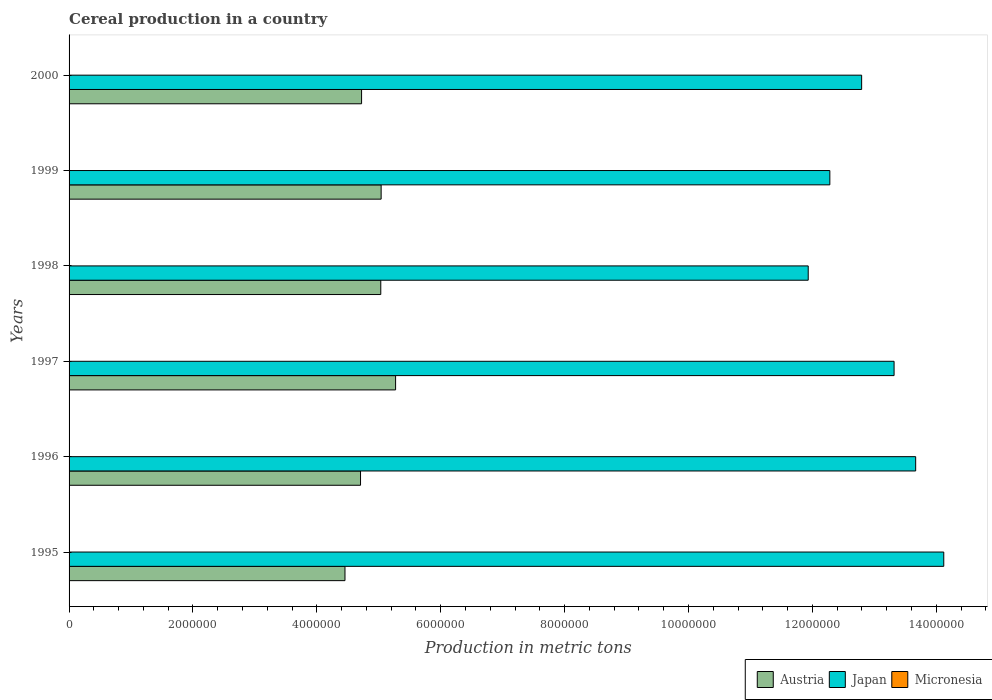Are the number of bars per tick equal to the number of legend labels?
Your response must be concise. Yes. Are the number of bars on each tick of the Y-axis equal?
Ensure brevity in your answer.  Yes. How many bars are there on the 3rd tick from the top?
Ensure brevity in your answer.  3. How many bars are there on the 4th tick from the bottom?
Your response must be concise. 3. In how many cases, is the number of bars for a given year not equal to the number of legend labels?
Your answer should be very brief. 0. What is the total cereal production in Austria in 1997?
Ensure brevity in your answer.  5.27e+06. Across all years, what is the maximum total cereal production in Austria?
Your answer should be very brief. 5.27e+06. Across all years, what is the minimum total cereal production in Japan?
Provide a short and direct response. 1.19e+07. In which year was the total cereal production in Japan maximum?
Offer a very short reply. 1995. What is the total total cereal production in Japan in the graph?
Keep it short and to the point. 7.81e+07. What is the difference between the total cereal production in Japan in 1996 and that in 1998?
Keep it short and to the point. 1.73e+06. What is the difference between the total cereal production in Micronesia in 1995 and the total cereal production in Japan in 1999?
Provide a succinct answer. -1.23e+07. What is the average total cereal production in Micronesia per year?
Keep it short and to the point. 148. In the year 2000, what is the difference between the total cereal production in Micronesia and total cereal production in Austria?
Keep it short and to the point. -4.72e+06. In how many years, is the total cereal production in Austria greater than 6000000 metric tons?
Your answer should be very brief. 0. What is the ratio of the total cereal production in Japan in 1997 to that in 1998?
Keep it short and to the point. 1.12. Is the difference between the total cereal production in Micronesia in 1999 and 2000 greater than the difference between the total cereal production in Austria in 1999 and 2000?
Your response must be concise. No. What is the difference between the highest and the second highest total cereal production in Austria?
Ensure brevity in your answer.  2.33e+05. What is the difference between the highest and the lowest total cereal production in Micronesia?
Ensure brevity in your answer.  23. What does the 3rd bar from the bottom in 1998 represents?
Ensure brevity in your answer.  Micronesia. How many bars are there?
Give a very brief answer. 18. Are all the bars in the graph horizontal?
Keep it short and to the point. Yes. What is the difference between two consecutive major ticks on the X-axis?
Your response must be concise. 2.00e+06. Does the graph contain any zero values?
Give a very brief answer. No. Does the graph contain grids?
Your response must be concise. No. Where does the legend appear in the graph?
Provide a succinct answer. Bottom right. What is the title of the graph?
Your answer should be compact. Cereal production in a country. Does "St. Lucia" appear as one of the legend labels in the graph?
Ensure brevity in your answer.  No. What is the label or title of the X-axis?
Provide a short and direct response. Production in metric tons. What is the label or title of the Y-axis?
Offer a very short reply. Years. What is the Production in metric tons in Austria in 1995?
Provide a short and direct response. 4.45e+06. What is the Production in metric tons of Japan in 1995?
Offer a very short reply. 1.41e+07. What is the Production in metric tons in Micronesia in 1995?
Provide a short and direct response. 148. What is the Production in metric tons in Austria in 1996?
Your answer should be compact. 4.71e+06. What is the Production in metric tons in Japan in 1996?
Your answer should be compact. 1.37e+07. What is the Production in metric tons of Micronesia in 1996?
Keep it short and to the point. 152. What is the Production in metric tons in Austria in 1997?
Ensure brevity in your answer.  5.27e+06. What is the Production in metric tons of Japan in 1997?
Ensure brevity in your answer.  1.33e+07. What is the Production in metric tons in Micronesia in 1997?
Provide a short and direct response. 149. What is the Production in metric tons of Austria in 1998?
Make the answer very short. 5.03e+06. What is the Production in metric tons in Japan in 1998?
Your response must be concise. 1.19e+07. What is the Production in metric tons in Micronesia in 1998?
Provide a succinct answer. 133. What is the Production in metric tons of Austria in 1999?
Make the answer very short. 5.04e+06. What is the Production in metric tons of Japan in 1999?
Give a very brief answer. 1.23e+07. What is the Production in metric tons of Micronesia in 1999?
Keep it short and to the point. 150. What is the Production in metric tons of Austria in 2000?
Provide a short and direct response. 4.72e+06. What is the Production in metric tons in Japan in 2000?
Offer a very short reply. 1.28e+07. What is the Production in metric tons in Micronesia in 2000?
Your response must be concise. 156. Across all years, what is the maximum Production in metric tons in Austria?
Your response must be concise. 5.27e+06. Across all years, what is the maximum Production in metric tons in Japan?
Provide a short and direct response. 1.41e+07. Across all years, what is the maximum Production in metric tons of Micronesia?
Offer a terse response. 156. Across all years, what is the minimum Production in metric tons of Austria?
Offer a very short reply. 4.45e+06. Across all years, what is the minimum Production in metric tons in Japan?
Provide a short and direct response. 1.19e+07. Across all years, what is the minimum Production in metric tons in Micronesia?
Give a very brief answer. 133. What is the total Production in metric tons in Austria in the graph?
Give a very brief answer. 2.92e+07. What is the total Production in metric tons of Japan in the graph?
Give a very brief answer. 7.81e+07. What is the total Production in metric tons in Micronesia in the graph?
Ensure brevity in your answer.  888. What is the difference between the Production in metric tons of Austria in 1995 and that in 1996?
Keep it short and to the point. -2.51e+05. What is the difference between the Production in metric tons of Japan in 1995 and that in 1996?
Give a very brief answer. 4.54e+05. What is the difference between the Production in metric tons in Micronesia in 1995 and that in 1996?
Give a very brief answer. -4. What is the difference between the Production in metric tons in Austria in 1995 and that in 1997?
Your response must be concise. -8.17e+05. What is the difference between the Production in metric tons of Japan in 1995 and that in 1997?
Keep it short and to the point. 8.02e+05. What is the difference between the Production in metric tons in Austria in 1995 and that in 1998?
Give a very brief answer. -5.78e+05. What is the difference between the Production in metric tons of Japan in 1995 and that in 1998?
Provide a succinct answer. 2.19e+06. What is the difference between the Production in metric tons in Austria in 1995 and that in 1999?
Your response must be concise. -5.84e+05. What is the difference between the Production in metric tons in Japan in 1995 and that in 1999?
Provide a succinct answer. 1.84e+06. What is the difference between the Production in metric tons of Austria in 1995 and that in 2000?
Keep it short and to the point. -2.68e+05. What is the difference between the Production in metric tons of Japan in 1995 and that in 2000?
Give a very brief answer. 1.33e+06. What is the difference between the Production in metric tons in Micronesia in 1995 and that in 2000?
Ensure brevity in your answer.  -8. What is the difference between the Production in metric tons of Austria in 1996 and that in 1997?
Ensure brevity in your answer.  -5.66e+05. What is the difference between the Production in metric tons of Japan in 1996 and that in 1997?
Your answer should be very brief. 3.48e+05. What is the difference between the Production in metric tons of Micronesia in 1996 and that in 1997?
Provide a short and direct response. 3. What is the difference between the Production in metric tons in Austria in 1996 and that in 1998?
Your answer should be compact. -3.27e+05. What is the difference between the Production in metric tons of Japan in 1996 and that in 1998?
Provide a short and direct response. 1.73e+06. What is the difference between the Production in metric tons of Micronesia in 1996 and that in 1998?
Your answer should be very brief. 19. What is the difference between the Production in metric tons of Austria in 1996 and that in 1999?
Provide a short and direct response. -3.33e+05. What is the difference between the Production in metric tons of Japan in 1996 and that in 1999?
Provide a short and direct response. 1.39e+06. What is the difference between the Production in metric tons of Austria in 1996 and that in 2000?
Your response must be concise. -1.68e+04. What is the difference between the Production in metric tons in Japan in 1996 and that in 2000?
Offer a very short reply. 8.72e+05. What is the difference between the Production in metric tons of Micronesia in 1996 and that in 2000?
Make the answer very short. -4. What is the difference between the Production in metric tons of Austria in 1997 and that in 1998?
Your answer should be very brief. 2.39e+05. What is the difference between the Production in metric tons in Japan in 1997 and that in 1998?
Provide a succinct answer. 1.39e+06. What is the difference between the Production in metric tons of Micronesia in 1997 and that in 1998?
Your answer should be compact. 16. What is the difference between the Production in metric tons of Austria in 1997 and that in 1999?
Provide a short and direct response. 2.33e+05. What is the difference between the Production in metric tons in Japan in 1997 and that in 1999?
Offer a terse response. 1.04e+06. What is the difference between the Production in metric tons in Micronesia in 1997 and that in 1999?
Give a very brief answer. -1. What is the difference between the Production in metric tons in Austria in 1997 and that in 2000?
Your answer should be very brief. 5.49e+05. What is the difference between the Production in metric tons in Japan in 1997 and that in 2000?
Your response must be concise. 5.24e+05. What is the difference between the Production in metric tons in Micronesia in 1997 and that in 2000?
Provide a short and direct response. -7. What is the difference between the Production in metric tons in Austria in 1998 and that in 1999?
Give a very brief answer. -5814. What is the difference between the Production in metric tons in Japan in 1998 and that in 1999?
Offer a terse response. -3.49e+05. What is the difference between the Production in metric tons in Micronesia in 1998 and that in 1999?
Your response must be concise. -17. What is the difference between the Production in metric tons of Austria in 1998 and that in 2000?
Provide a succinct answer. 3.10e+05. What is the difference between the Production in metric tons of Japan in 1998 and that in 2000?
Keep it short and to the point. -8.62e+05. What is the difference between the Production in metric tons in Austria in 1999 and that in 2000?
Make the answer very short. 3.16e+05. What is the difference between the Production in metric tons in Japan in 1999 and that in 2000?
Provide a short and direct response. -5.13e+05. What is the difference between the Production in metric tons of Micronesia in 1999 and that in 2000?
Offer a terse response. -6. What is the difference between the Production in metric tons of Austria in 1995 and the Production in metric tons of Japan in 1996?
Ensure brevity in your answer.  -9.21e+06. What is the difference between the Production in metric tons of Austria in 1995 and the Production in metric tons of Micronesia in 1996?
Provide a succinct answer. 4.45e+06. What is the difference between the Production in metric tons of Japan in 1995 and the Production in metric tons of Micronesia in 1996?
Provide a succinct answer. 1.41e+07. What is the difference between the Production in metric tons in Austria in 1995 and the Production in metric tons in Japan in 1997?
Your answer should be very brief. -8.87e+06. What is the difference between the Production in metric tons of Austria in 1995 and the Production in metric tons of Micronesia in 1997?
Keep it short and to the point. 4.45e+06. What is the difference between the Production in metric tons of Japan in 1995 and the Production in metric tons of Micronesia in 1997?
Ensure brevity in your answer.  1.41e+07. What is the difference between the Production in metric tons in Austria in 1995 and the Production in metric tons in Japan in 1998?
Provide a succinct answer. -7.48e+06. What is the difference between the Production in metric tons in Austria in 1995 and the Production in metric tons in Micronesia in 1998?
Ensure brevity in your answer.  4.45e+06. What is the difference between the Production in metric tons of Japan in 1995 and the Production in metric tons of Micronesia in 1998?
Offer a terse response. 1.41e+07. What is the difference between the Production in metric tons of Austria in 1995 and the Production in metric tons of Japan in 1999?
Ensure brevity in your answer.  -7.83e+06. What is the difference between the Production in metric tons in Austria in 1995 and the Production in metric tons in Micronesia in 1999?
Ensure brevity in your answer.  4.45e+06. What is the difference between the Production in metric tons in Japan in 1995 and the Production in metric tons in Micronesia in 1999?
Ensure brevity in your answer.  1.41e+07. What is the difference between the Production in metric tons of Austria in 1995 and the Production in metric tons of Japan in 2000?
Make the answer very short. -8.34e+06. What is the difference between the Production in metric tons of Austria in 1995 and the Production in metric tons of Micronesia in 2000?
Offer a very short reply. 4.45e+06. What is the difference between the Production in metric tons in Japan in 1995 and the Production in metric tons in Micronesia in 2000?
Provide a succinct answer. 1.41e+07. What is the difference between the Production in metric tons of Austria in 1996 and the Production in metric tons of Japan in 1997?
Provide a succinct answer. -8.61e+06. What is the difference between the Production in metric tons of Austria in 1996 and the Production in metric tons of Micronesia in 1997?
Offer a very short reply. 4.71e+06. What is the difference between the Production in metric tons of Japan in 1996 and the Production in metric tons of Micronesia in 1997?
Ensure brevity in your answer.  1.37e+07. What is the difference between the Production in metric tons of Austria in 1996 and the Production in metric tons of Japan in 1998?
Keep it short and to the point. -7.23e+06. What is the difference between the Production in metric tons in Austria in 1996 and the Production in metric tons in Micronesia in 1998?
Make the answer very short. 4.71e+06. What is the difference between the Production in metric tons of Japan in 1996 and the Production in metric tons of Micronesia in 1998?
Give a very brief answer. 1.37e+07. What is the difference between the Production in metric tons in Austria in 1996 and the Production in metric tons in Japan in 1999?
Provide a short and direct response. -7.58e+06. What is the difference between the Production in metric tons in Austria in 1996 and the Production in metric tons in Micronesia in 1999?
Ensure brevity in your answer.  4.71e+06. What is the difference between the Production in metric tons of Japan in 1996 and the Production in metric tons of Micronesia in 1999?
Offer a terse response. 1.37e+07. What is the difference between the Production in metric tons in Austria in 1996 and the Production in metric tons in Japan in 2000?
Offer a very short reply. -8.09e+06. What is the difference between the Production in metric tons in Austria in 1996 and the Production in metric tons in Micronesia in 2000?
Ensure brevity in your answer.  4.71e+06. What is the difference between the Production in metric tons of Japan in 1996 and the Production in metric tons of Micronesia in 2000?
Give a very brief answer. 1.37e+07. What is the difference between the Production in metric tons in Austria in 1997 and the Production in metric tons in Japan in 1998?
Your answer should be compact. -6.66e+06. What is the difference between the Production in metric tons in Austria in 1997 and the Production in metric tons in Micronesia in 1998?
Give a very brief answer. 5.27e+06. What is the difference between the Production in metric tons of Japan in 1997 and the Production in metric tons of Micronesia in 1998?
Give a very brief answer. 1.33e+07. What is the difference between the Production in metric tons in Austria in 1997 and the Production in metric tons in Japan in 1999?
Provide a succinct answer. -7.01e+06. What is the difference between the Production in metric tons of Austria in 1997 and the Production in metric tons of Micronesia in 1999?
Your answer should be very brief. 5.27e+06. What is the difference between the Production in metric tons in Japan in 1997 and the Production in metric tons in Micronesia in 1999?
Keep it short and to the point. 1.33e+07. What is the difference between the Production in metric tons of Austria in 1997 and the Production in metric tons of Japan in 2000?
Provide a succinct answer. -7.52e+06. What is the difference between the Production in metric tons in Austria in 1997 and the Production in metric tons in Micronesia in 2000?
Give a very brief answer. 5.27e+06. What is the difference between the Production in metric tons of Japan in 1997 and the Production in metric tons of Micronesia in 2000?
Provide a succinct answer. 1.33e+07. What is the difference between the Production in metric tons of Austria in 1998 and the Production in metric tons of Japan in 1999?
Keep it short and to the point. -7.25e+06. What is the difference between the Production in metric tons in Austria in 1998 and the Production in metric tons in Micronesia in 1999?
Ensure brevity in your answer.  5.03e+06. What is the difference between the Production in metric tons of Japan in 1998 and the Production in metric tons of Micronesia in 1999?
Make the answer very short. 1.19e+07. What is the difference between the Production in metric tons of Austria in 1998 and the Production in metric tons of Japan in 2000?
Offer a very short reply. -7.76e+06. What is the difference between the Production in metric tons in Austria in 1998 and the Production in metric tons in Micronesia in 2000?
Your answer should be compact. 5.03e+06. What is the difference between the Production in metric tons in Japan in 1998 and the Production in metric tons in Micronesia in 2000?
Your answer should be very brief. 1.19e+07. What is the difference between the Production in metric tons in Austria in 1999 and the Production in metric tons in Japan in 2000?
Offer a terse response. -7.76e+06. What is the difference between the Production in metric tons in Austria in 1999 and the Production in metric tons in Micronesia in 2000?
Give a very brief answer. 5.04e+06. What is the difference between the Production in metric tons of Japan in 1999 and the Production in metric tons of Micronesia in 2000?
Your answer should be very brief. 1.23e+07. What is the average Production in metric tons of Austria per year?
Keep it short and to the point. 4.87e+06. What is the average Production in metric tons in Japan per year?
Your answer should be very brief. 1.30e+07. What is the average Production in metric tons in Micronesia per year?
Give a very brief answer. 148. In the year 1995, what is the difference between the Production in metric tons of Austria and Production in metric tons of Japan?
Offer a terse response. -9.67e+06. In the year 1995, what is the difference between the Production in metric tons of Austria and Production in metric tons of Micronesia?
Provide a succinct answer. 4.45e+06. In the year 1995, what is the difference between the Production in metric tons of Japan and Production in metric tons of Micronesia?
Make the answer very short. 1.41e+07. In the year 1996, what is the difference between the Production in metric tons in Austria and Production in metric tons in Japan?
Give a very brief answer. -8.96e+06. In the year 1996, what is the difference between the Production in metric tons of Austria and Production in metric tons of Micronesia?
Provide a short and direct response. 4.71e+06. In the year 1996, what is the difference between the Production in metric tons of Japan and Production in metric tons of Micronesia?
Provide a short and direct response. 1.37e+07. In the year 1997, what is the difference between the Production in metric tons of Austria and Production in metric tons of Japan?
Your answer should be compact. -8.05e+06. In the year 1997, what is the difference between the Production in metric tons of Austria and Production in metric tons of Micronesia?
Keep it short and to the point. 5.27e+06. In the year 1997, what is the difference between the Production in metric tons in Japan and Production in metric tons in Micronesia?
Provide a succinct answer. 1.33e+07. In the year 1998, what is the difference between the Production in metric tons of Austria and Production in metric tons of Japan?
Your response must be concise. -6.90e+06. In the year 1998, what is the difference between the Production in metric tons in Austria and Production in metric tons in Micronesia?
Offer a terse response. 5.03e+06. In the year 1998, what is the difference between the Production in metric tons of Japan and Production in metric tons of Micronesia?
Provide a short and direct response. 1.19e+07. In the year 1999, what is the difference between the Production in metric tons in Austria and Production in metric tons in Japan?
Provide a short and direct response. -7.24e+06. In the year 1999, what is the difference between the Production in metric tons in Austria and Production in metric tons in Micronesia?
Ensure brevity in your answer.  5.04e+06. In the year 1999, what is the difference between the Production in metric tons of Japan and Production in metric tons of Micronesia?
Ensure brevity in your answer.  1.23e+07. In the year 2000, what is the difference between the Production in metric tons in Austria and Production in metric tons in Japan?
Ensure brevity in your answer.  -8.07e+06. In the year 2000, what is the difference between the Production in metric tons of Austria and Production in metric tons of Micronesia?
Your answer should be very brief. 4.72e+06. In the year 2000, what is the difference between the Production in metric tons in Japan and Production in metric tons in Micronesia?
Give a very brief answer. 1.28e+07. What is the ratio of the Production in metric tons in Austria in 1995 to that in 1996?
Ensure brevity in your answer.  0.95. What is the ratio of the Production in metric tons of Japan in 1995 to that in 1996?
Ensure brevity in your answer.  1.03. What is the ratio of the Production in metric tons of Micronesia in 1995 to that in 1996?
Make the answer very short. 0.97. What is the ratio of the Production in metric tons in Austria in 1995 to that in 1997?
Ensure brevity in your answer.  0.84. What is the ratio of the Production in metric tons in Japan in 1995 to that in 1997?
Provide a succinct answer. 1.06. What is the ratio of the Production in metric tons of Micronesia in 1995 to that in 1997?
Offer a terse response. 0.99. What is the ratio of the Production in metric tons in Austria in 1995 to that in 1998?
Provide a short and direct response. 0.89. What is the ratio of the Production in metric tons of Japan in 1995 to that in 1998?
Provide a succinct answer. 1.18. What is the ratio of the Production in metric tons of Micronesia in 1995 to that in 1998?
Provide a succinct answer. 1.11. What is the ratio of the Production in metric tons of Austria in 1995 to that in 1999?
Offer a terse response. 0.88. What is the ratio of the Production in metric tons of Japan in 1995 to that in 1999?
Your response must be concise. 1.15. What is the ratio of the Production in metric tons in Micronesia in 1995 to that in 1999?
Provide a succinct answer. 0.99. What is the ratio of the Production in metric tons of Austria in 1995 to that in 2000?
Your answer should be very brief. 0.94. What is the ratio of the Production in metric tons in Japan in 1995 to that in 2000?
Offer a very short reply. 1.1. What is the ratio of the Production in metric tons of Micronesia in 1995 to that in 2000?
Your answer should be very brief. 0.95. What is the ratio of the Production in metric tons of Austria in 1996 to that in 1997?
Make the answer very short. 0.89. What is the ratio of the Production in metric tons in Japan in 1996 to that in 1997?
Give a very brief answer. 1.03. What is the ratio of the Production in metric tons in Micronesia in 1996 to that in 1997?
Provide a succinct answer. 1.02. What is the ratio of the Production in metric tons of Austria in 1996 to that in 1998?
Your response must be concise. 0.94. What is the ratio of the Production in metric tons in Japan in 1996 to that in 1998?
Keep it short and to the point. 1.15. What is the ratio of the Production in metric tons in Micronesia in 1996 to that in 1998?
Provide a succinct answer. 1.14. What is the ratio of the Production in metric tons in Austria in 1996 to that in 1999?
Your response must be concise. 0.93. What is the ratio of the Production in metric tons of Japan in 1996 to that in 1999?
Provide a short and direct response. 1.11. What is the ratio of the Production in metric tons of Micronesia in 1996 to that in 1999?
Make the answer very short. 1.01. What is the ratio of the Production in metric tons of Austria in 1996 to that in 2000?
Give a very brief answer. 1. What is the ratio of the Production in metric tons in Japan in 1996 to that in 2000?
Your answer should be compact. 1.07. What is the ratio of the Production in metric tons in Micronesia in 1996 to that in 2000?
Offer a terse response. 0.97. What is the ratio of the Production in metric tons of Austria in 1997 to that in 1998?
Give a very brief answer. 1.05. What is the ratio of the Production in metric tons of Japan in 1997 to that in 1998?
Provide a short and direct response. 1.12. What is the ratio of the Production in metric tons of Micronesia in 1997 to that in 1998?
Your answer should be compact. 1.12. What is the ratio of the Production in metric tons of Austria in 1997 to that in 1999?
Offer a very short reply. 1.05. What is the ratio of the Production in metric tons in Japan in 1997 to that in 1999?
Ensure brevity in your answer.  1.08. What is the ratio of the Production in metric tons of Austria in 1997 to that in 2000?
Your answer should be very brief. 1.12. What is the ratio of the Production in metric tons of Japan in 1997 to that in 2000?
Your answer should be compact. 1.04. What is the ratio of the Production in metric tons in Micronesia in 1997 to that in 2000?
Your answer should be very brief. 0.96. What is the ratio of the Production in metric tons in Japan in 1998 to that in 1999?
Provide a short and direct response. 0.97. What is the ratio of the Production in metric tons in Micronesia in 1998 to that in 1999?
Give a very brief answer. 0.89. What is the ratio of the Production in metric tons of Austria in 1998 to that in 2000?
Make the answer very short. 1.07. What is the ratio of the Production in metric tons in Japan in 1998 to that in 2000?
Provide a succinct answer. 0.93. What is the ratio of the Production in metric tons of Micronesia in 1998 to that in 2000?
Ensure brevity in your answer.  0.85. What is the ratio of the Production in metric tons of Austria in 1999 to that in 2000?
Ensure brevity in your answer.  1.07. What is the ratio of the Production in metric tons in Japan in 1999 to that in 2000?
Provide a short and direct response. 0.96. What is the ratio of the Production in metric tons of Micronesia in 1999 to that in 2000?
Make the answer very short. 0.96. What is the difference between the highest and the second highest Production in metric tons in Austria?
Provide a succinct answer. 2.33e+05. What is the difference between the highest and the second highest Production in metric tons of Japan?
Provide a succinct answer. 4.54e+05. What is the difference between the highest and the lowest Production in metric tons of Austria?
Make the answer very short. 8.17e+05. What is the difference between the highest and the lowest Production in metric tons in Japan?
Your response must be concise. 2.19e+06. What is the difference between the highest and the lowest Production in metric tons of Micronesia?
Provide a succinct answer. 23. 